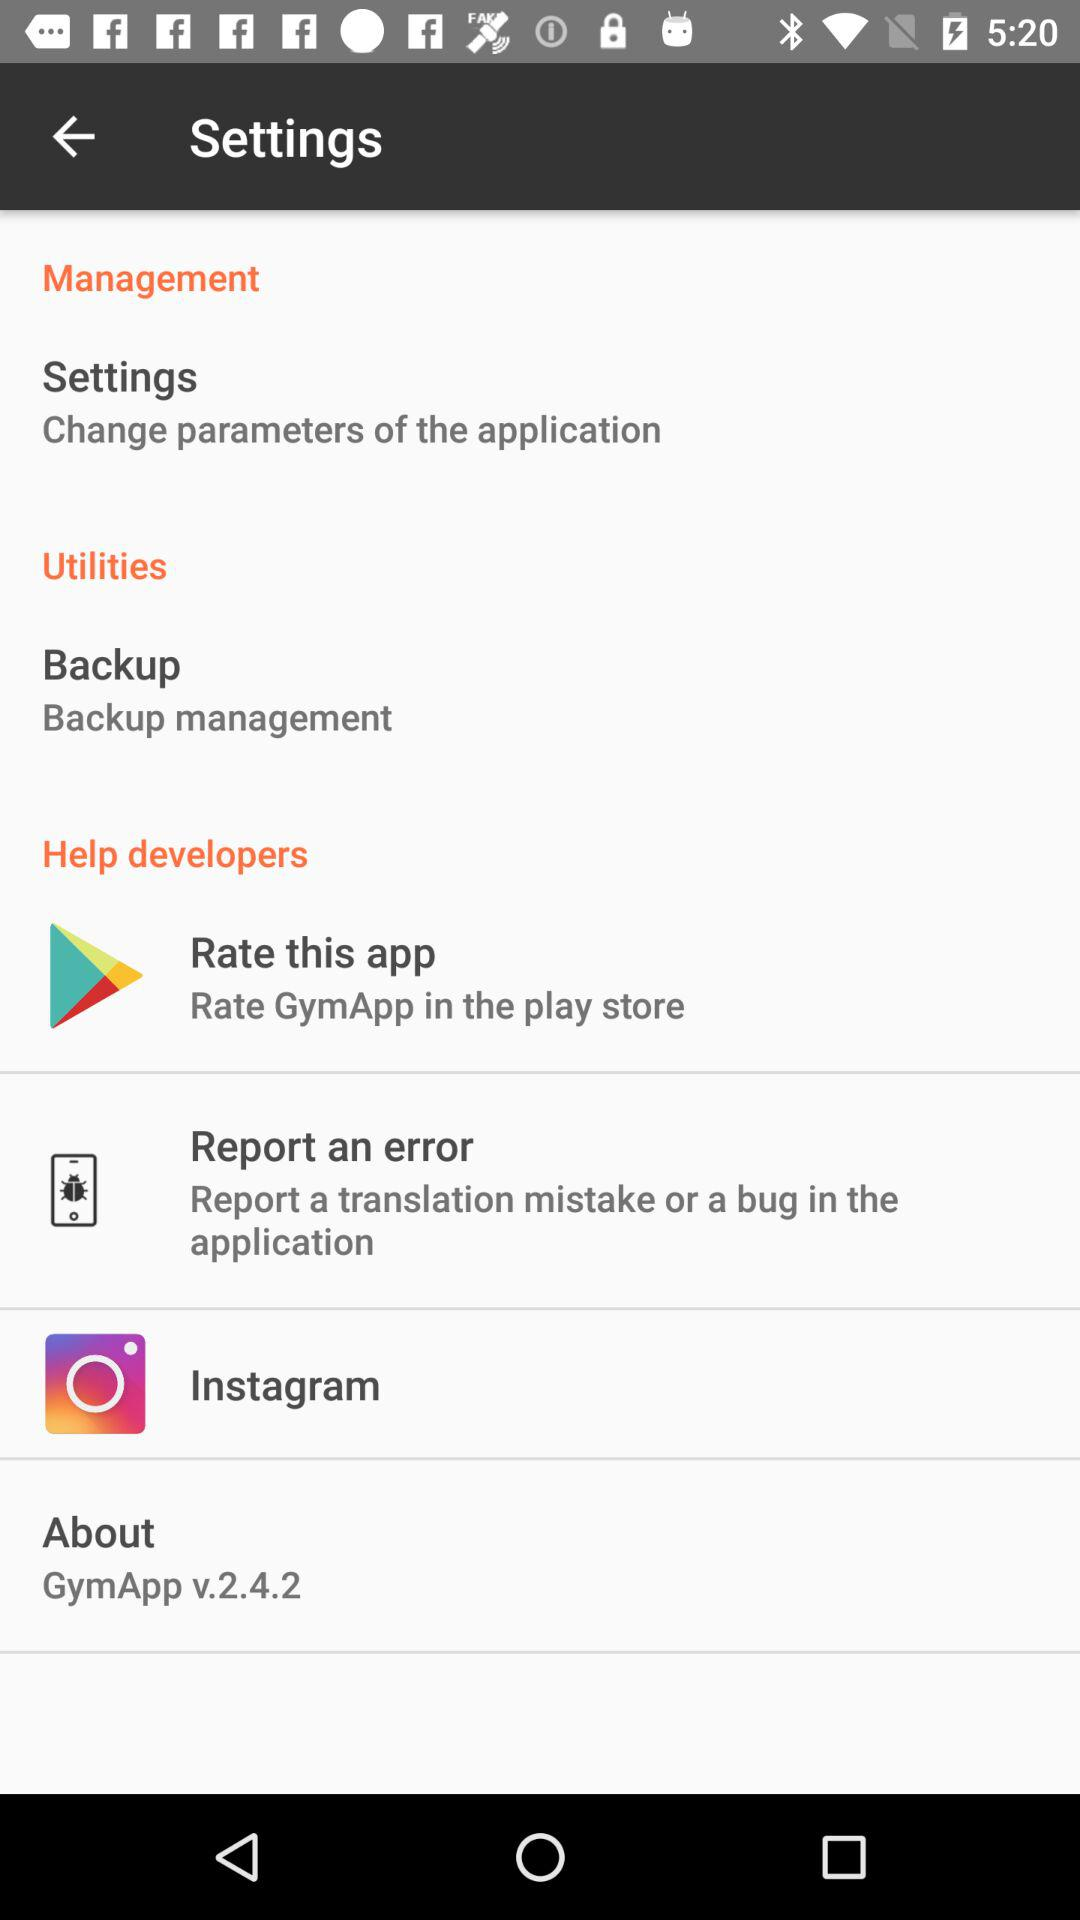Where can you rate "GymApp"? You can rate the "GymApp" in "play store". 